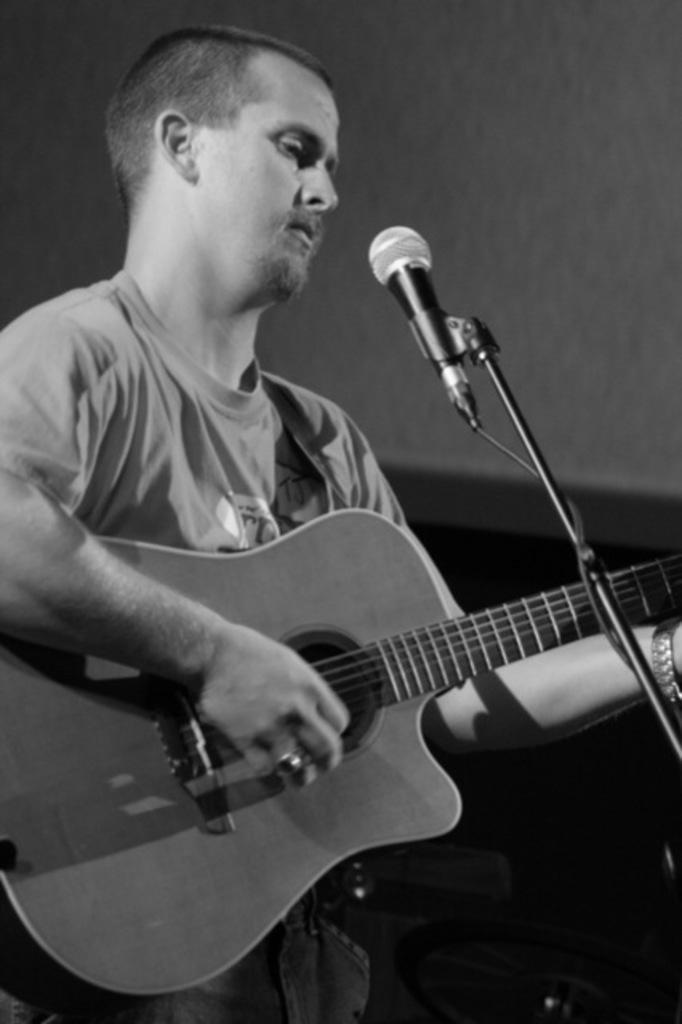What is the man in the image holding? The man is holding a guitar. What is the man positioned in front of in the image? The man is in front of a microphone. What type of clothing is the man wearing? The man is wearing a t-shirt. What type of wall can be seen behind the man in the image? There is no wall visible behind the man in the image; he is in front of a microphone. 